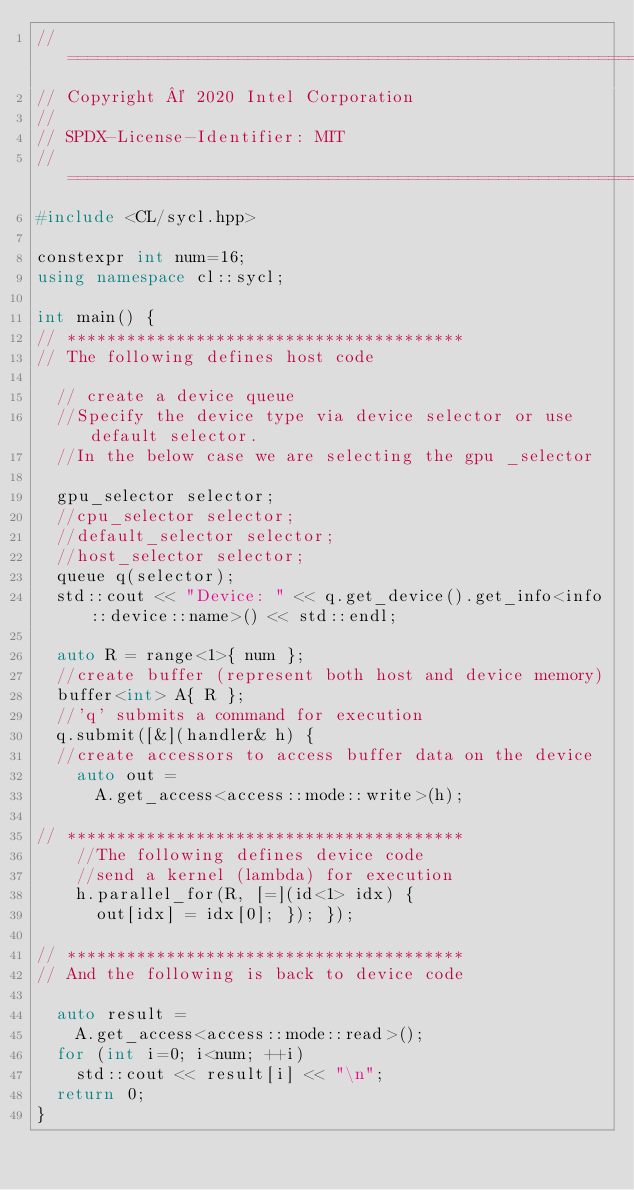Convert code to text. <code><loc_0><loc_0><loc_500><loc_500><_C++_>//==============================================================
// Copyright © 2020 Intel Corporation
//
// SPDX-License-Identifier: MIT
// =============================================================
#include <CL/sycl.hpp>

constexpr int num=16;
using namespace cl::sycl;

int main() {
// ****************************************
// The following defines host code
    
  // create a device queue
  //Specify the device type via device selector or use default selector.
  //In the below case we are selecting the gpu _selector    
  
  gpu_selector selector;
  //cpu_selector selector;
  //default_selector selector;
  //host_selector selector;
  queue q(selector);
  std::cout << "Device: " << q.get_device().get_info<info::device::name>() << std::endl;
    
  auto R = range<1>{ num };
  //create buffer (represent both host and device memory)
  buffer<int> A{ R };
  //'q' submits a command for execution
  q.submit([&](handler& h) {
  //create accessors to access buffer data on the device
    auto out =
      A.get_access<access::mode::write>(h);

// ****************************************
    //The following defines device code
    //send a kernel (lambda) for execution  
    h.parallel_for(R, [=](id<1> idx) {
      out[idx] = idx[0]; }); });

// ****************************************
// And the following is back to device code
  
  auto result =
    A.get_access<access::mode::read>();
  for (int i=0; i<num; ++i)
    std::cout << result[i] << "\n";
  return 0;
}</code> 